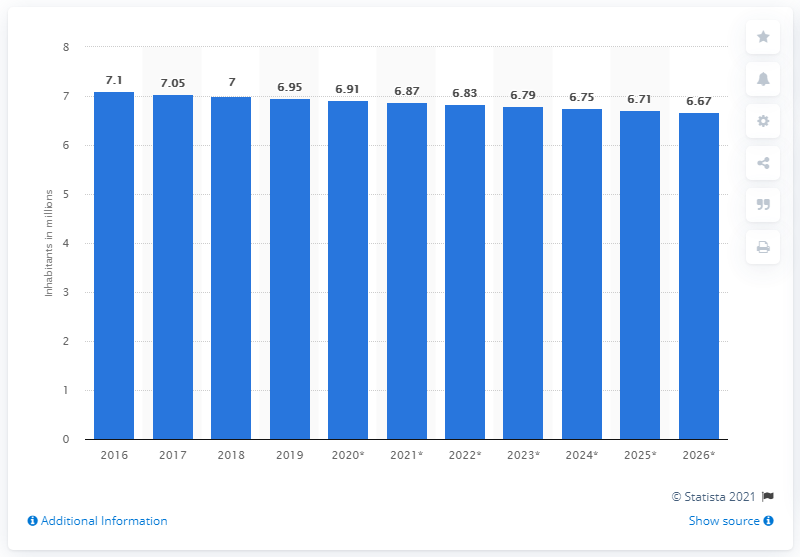Mention a couple of crucial points in this snapshot. In 2019, Bulgaria's population was 6.91 million. 